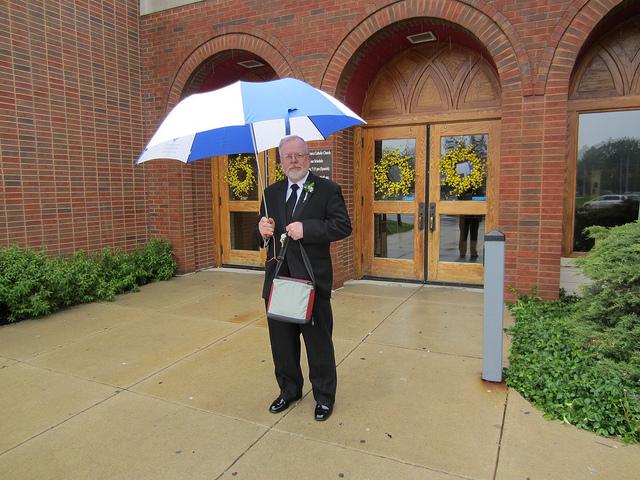What is the color of the umbrella?
Quick response, please. Blue and white. What color is the umbrella on the right?
Write a very short answer. Blue and white. Are there flowers?
Give a very brief answer. Yes. Does the man need an umbrella?
Give a very brief answer. No. Is the man bold?
Concise answer only. No. Is he the only person holding an umbrella?
Give a very brief answer. Yes. Which umbrella is not solid colored?
Quick response, please. Blue-and-white one. Does the building have brick facade exterior?
Give a very brief answer. Yes. 